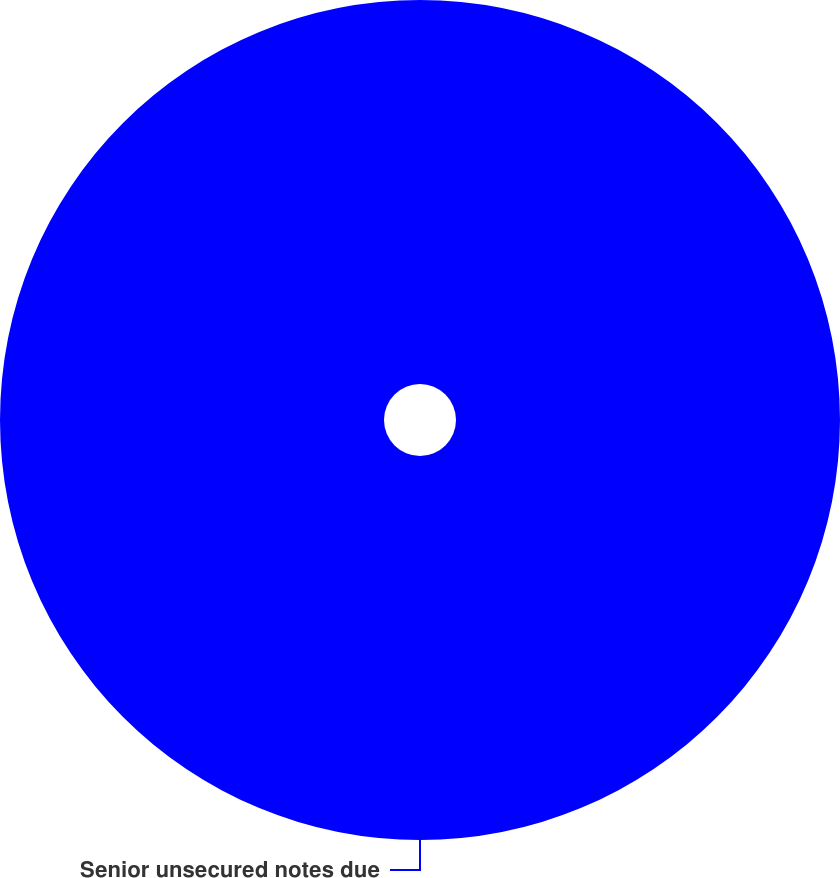Convert chart. <chart><loc_0><loc_0><loc_500><loc_500><pie_chart><fcel>Senior unsecured notes due<nl><fcel>100.0%<nl></chart> 